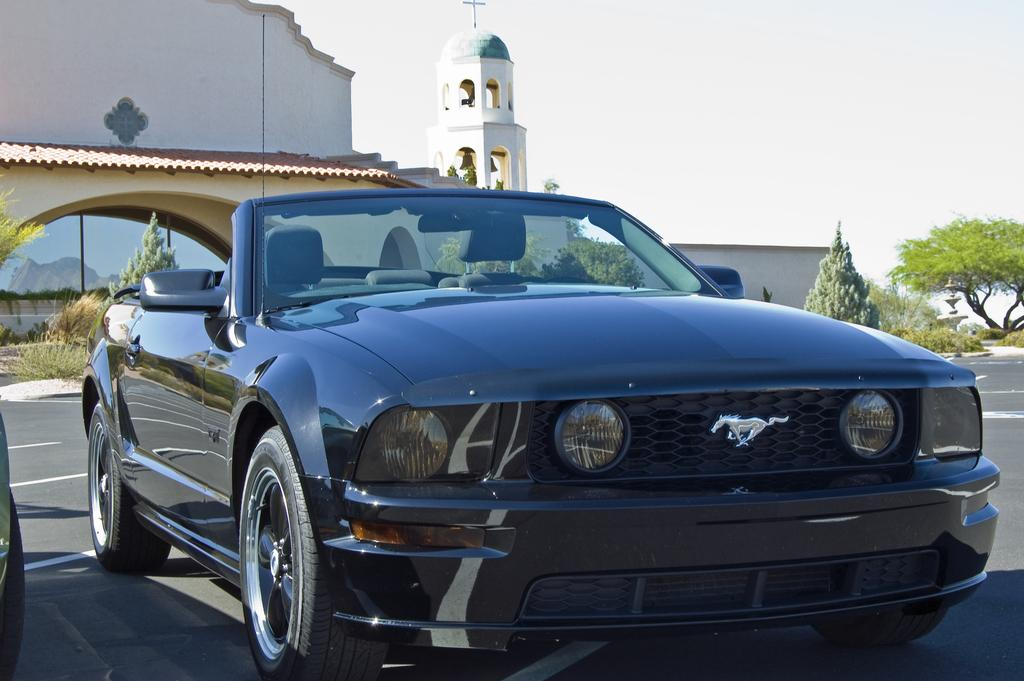What is on the road in the image? There is a vehicle on the road in the image. What type of natural elements can be seen in the image? There are trees and plants in the image. What type of man-made structures are present in the image? There is a building, a wall, and a shed in the image. What part of the natural environment is visible in the background of the image? The sky is visible in the background of the image. How many ladybugs are crawling on the vehicle in the image? There are no ladybugs present in the image; it only features a vehicle on the road. What type of calendar is hanging on the wall in the image? There is no calendar present in the image; it only features a wall and other structures. 